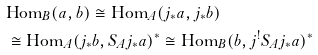Convert formula to latex. <formula><loc_0><loc_0><loc_500><loc_500>& \text {Hom} _ { B } ( a , b ) \cong \text {Hom} _ { A } ( j _ { * } a , j _ { * } b ) \\ & \cong \text {Hom} _ { A } ( j _ { * } b , S _ { A } j _ { * } a ) ^ { * } \cong \text {Hom} _ { B } ( b , j ^ { ! } S _ { A } j _ { * } a ) ^ { * }</formula> 